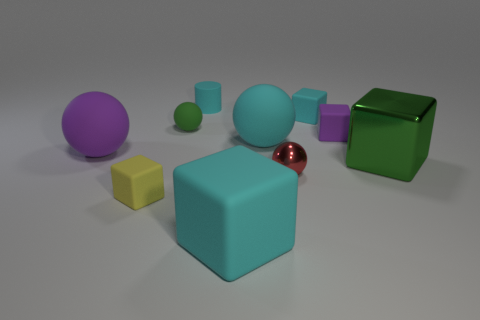The tiny cyan matte object on the right side of the cyan matte cube in front of the rubber sphere on the right side of the big matte block is what shape?
Ensure brevity in your answer.  Cube. What number of other things are the same shape as the large shiny object?
Offer a very short reply. 4. What is the material of the ball that is in front of the sphere to the left of the green sphere?
Your response must be concise. Metal. Is the tiny cyan block made of the same material as the green thing that is on the right side of the tiny metal object?
Offer a very short reply. No. The cyan object that is both behind the purple cube and left of the tiny cyan matte block is made of what material?
Your answer should be compact. Rubber. There is a big object that is on the left side of the block that is to the left of the small cyan matte cylinder; what color is it?
Provide a succinct answer. Purple. There is a large block that is to the right of the small purple matte block; what material is it?
Ensure brevity in your answer.  Metal. Is the number of metal things less than the number of tiny blue shiny blocks?
Make the answer very short. No. There is a big purple matte object; does it have the same shape as the large matte object that is behind the large purple thing?
Keep it short and to the point. Yes. There is a object that is both on the right side of the big cyan matte ball and in front of the green shiny cube; what is its shape?
Provide a succinct answer. Sphere. 